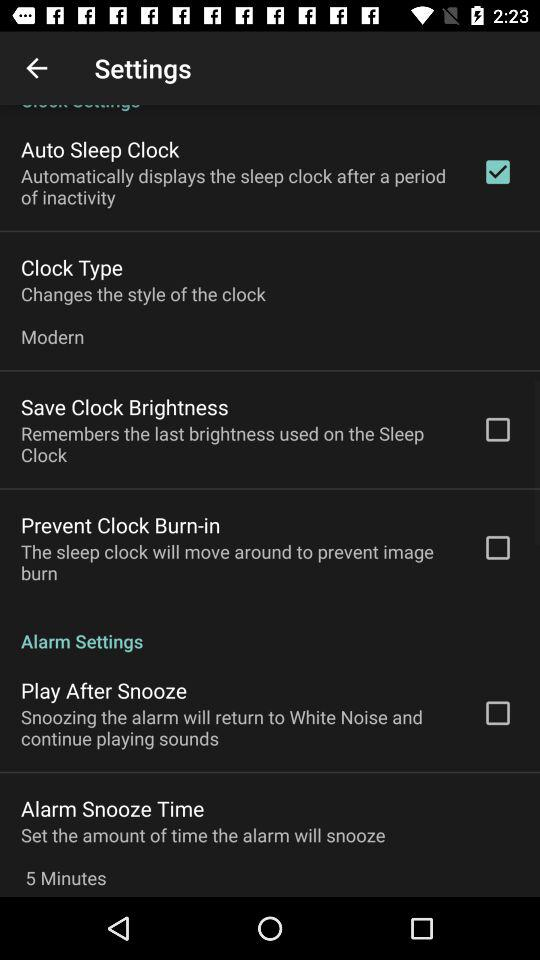What is the name of the application?
When the provided information is insufficient, respond with <no answer>. <no answer> 